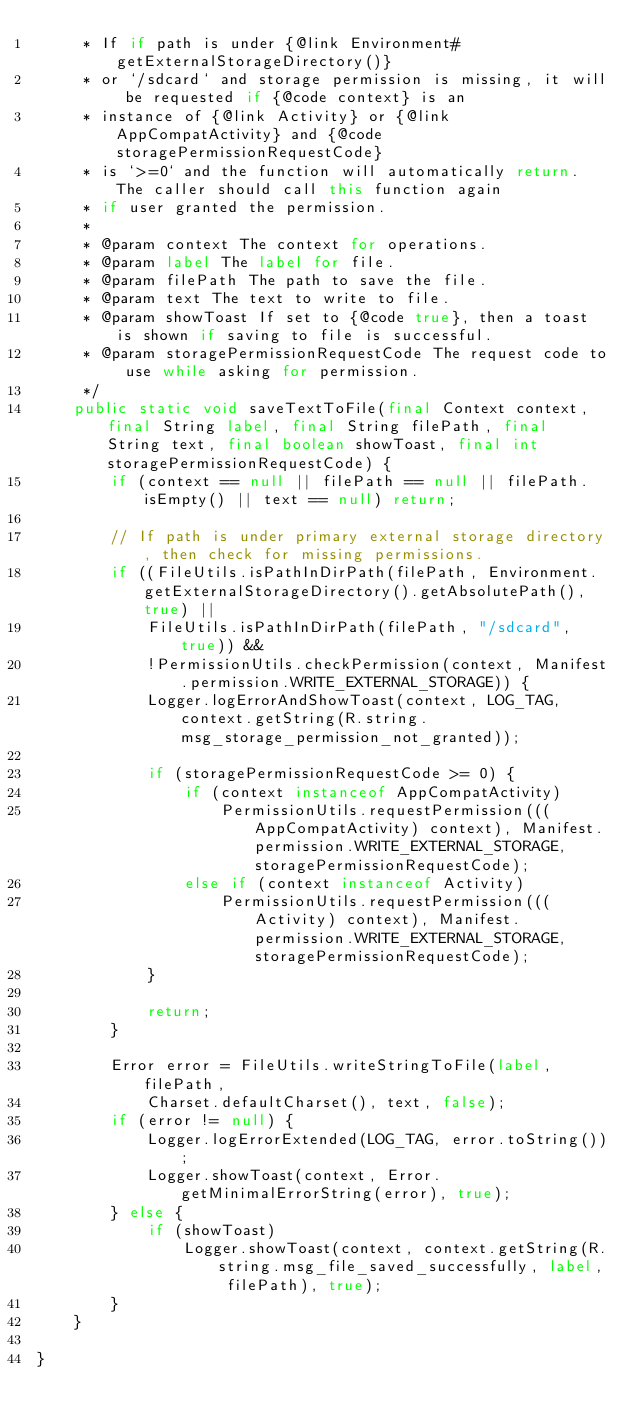Convert code to text. <code><loc_0><loc_0><loc_500><loc_500><_Java_>     * If if path is under {@link Environment#getExternalStorageDirectory()}
     * or `/sdcard` and storage permission is missing, it will be requested if {@code context} is an
     * instance of {@link Activity} or {@link AppCompatActivity} and {@code storagePermissionRequestCode}
     * is `>=0` and the function will automatically return. The caller should call this function again
     * if user granted the permission.
     *
     * @param context The context for operations.
     * @param label The label for file.
     * @param filePath The path to save the file.
     * @param text The text to write to file.
     * @param showToast If set to {@code true}, then a toast is shown if saving to file is successful.
     * @param storagePermissionRequestCode The request code to use while asking for permission.
     */
    public static void saveTextToFile(final Context context, final String label, final String filePath, final String text, final boolean showToast, final int storagePermissionRequestCode) {
        if (context == null || filePath == null || filePath.isEmpty() || text == null) return;

        // If path is under primary external storage directory, then check for missing permissions.
        if ((FileUtils.isPathInDirPath(filePath, Environment.getExternalStorageDirectory().getAbsolutePath(), true) ||
            FileUtils.isPathInDirPath(filePath, "/sdcard", true)) &&
            !PermissionUtils.checkPermission(context, Manifest.permission.WRITE_EXTERNAL_STORAGE)) {
            Logger.logErrorAndShowToast(context, LOG_TAG, context.getString(R.string.msg_storage_permission_not_granted));

            if (storagePermissionRequestCode >= 0) {
                if (context instanceof AppCompatActivity)
                    PermissionUtils.requestPermission(((AppCompatActivity) context), Manifest.permission.WRITE_EXTERNAL_STORAGE, storagePermissionRequestCode);
                else if (context instanceof Activity)
                    PermissionUtils.requestPermission(((Activity) context), Manifest.permission.WRITE_EXTERNAL_STORAGE, storagePermissionRequestCode);
            }

            return;
        }

        Error error = FileUtils.writeStringToFile(label, filePath,
            Charset.defaultCharset(), text, false);
        if (error != null) {
            Logger.logErrorExtended(LOG_TAG, error.toString());
            Logger.showToast(context, Error.getMinimalErrorString(error), true);
        } else {
            if (showToast)
                Logger.showToast(context, context.getString(R.string.msg_file_saved_successfully, label, filePath), true);
        }
    }

}
</code> 